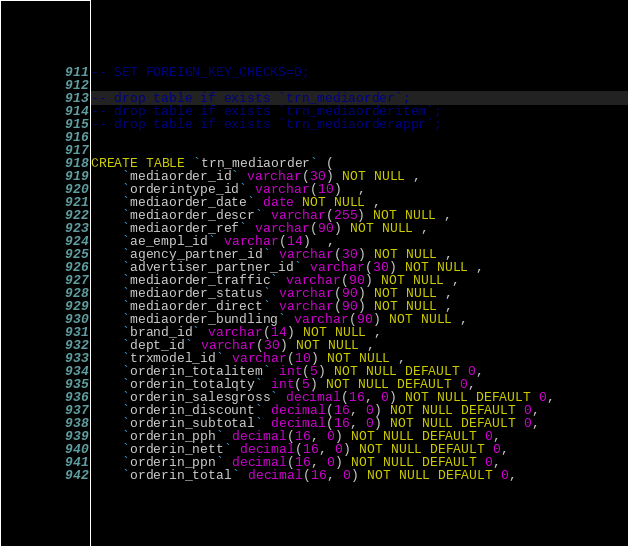<code> <loc_0><loc_0><loc_500><loc_500><_SQL_>-- SET FOREIGN_KEY_CHECKS=0;

-- drop table if exists `trn_mediaorder`;
-- drop table if exists `trn_mediaorderitem`;
-- drop table if exists `trn_mediaorderappr`;


CREATE TABLE `trn_mediaorder` (
	`mediaorder_id` varchar(30) NOT NULL , 
	`orderintype_id` varchar(10)  , 
	`mediaorder_date` date NOT NULL , 
	`mediaorder_descr` varchar(255) NOT NULL , 
	`mediaorder_ref` varchar(90) NOT NULL , 
	`ae_empl_id` varchar(14)  , 
	`agency_partner_id` varchar(30) NOT NULL , 
	`advertiser_partner_id` varchar(30) NOT NULL , 
	`mediaorder_traffic` varchar(90) NOT NULL , 
	`mediaorder_status` varchar(90) NOT NULL , 
	`mediaorder_direct` varchar(90) NOT NULL , 
	`mediaorder_bundling` varchar(90) NOT NULL , 
	`brand_id` varchar(14) NOT NULL , 
	`dept_id` varchar(30) NOT NULL , 
	`trxmodel_id` varchar(10) NOT NULL , 
	`orderin_totalitem` int(5) NOT NULL DEFAULT 0, 
	`orderin_totalqty` int(5) NOT NULL DEFAULT 0, 
	`orderin_salesgross` decimal(16, 0) NOT NULL DEFAULT 0, 
	`orderin_discount` decimal(16, 0) NOT NULL DEFAULT 0, 
	`orderin_subtotal` decimal(16, 0) NOT NULL DEFAULT 0, 
	`orderin_pph` decimal(16, 0) NOT NULL DEFAULT 0, 
	`orderin_nett` decimal(16, 0) NOT NULL DEFAULT 0, 
	`orderin_ppn` decimal(16, 0) NOT NULL DEFAULT 0, 
	`orderin_total` decimal(16, 0) NOT NULL DEFAULT 0, </code> 